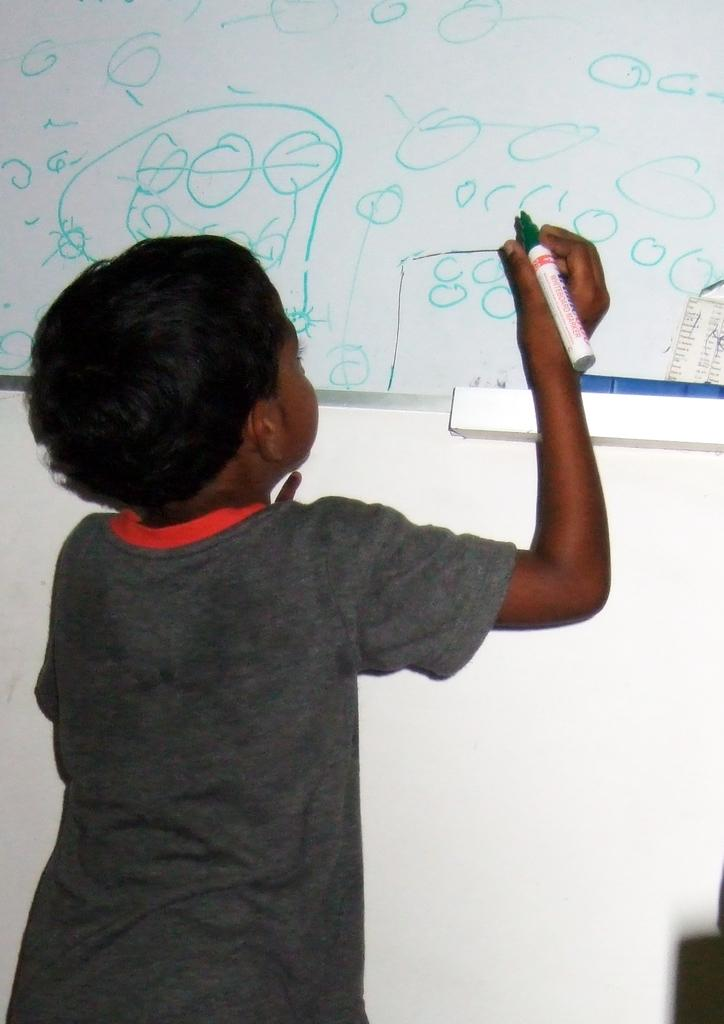Who is the main subject in the image? There is a boy in the image. What is the boy doing in the image? The boy is standing in the image. What is the boy holding in his hand? The boy is holding a marker in his hand. What is the white object in the image? There is a white color board in the image. What can be seen on the white color board? Something is written on the white color board. What type of pan is the actor using in the image? There is no actor or pan present in the image. Is the boy wearing a mask in the image? There is no mask visible on the boy in the image. 